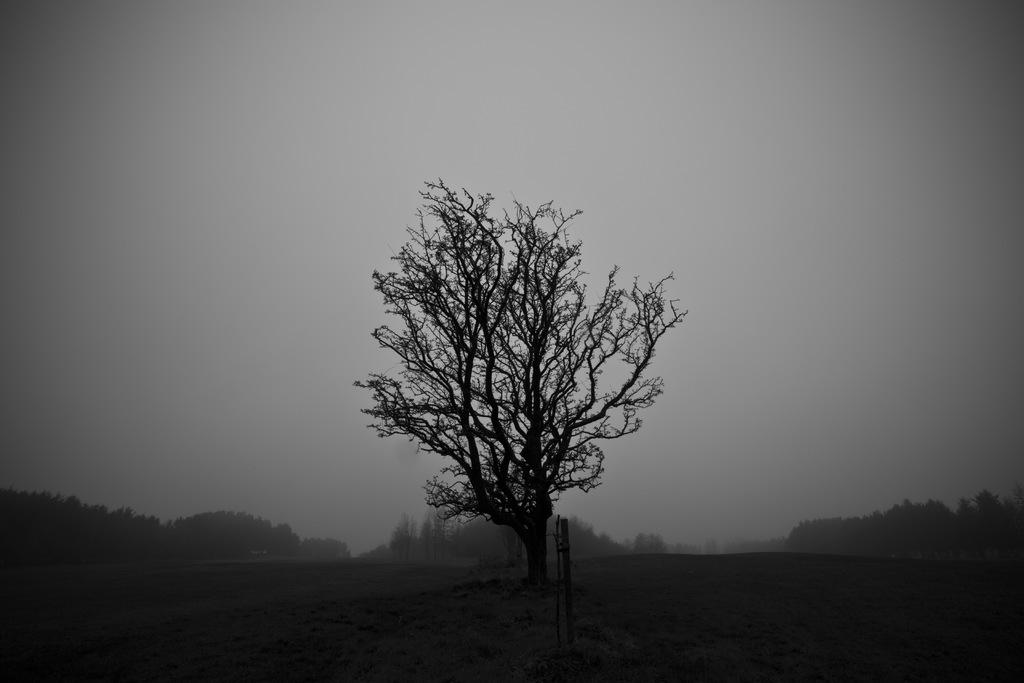What is the main subject in the center of the image? There is a tree in the center of the image. What can be seen in the background of the image? There are many trees in the background of the image. What is visible at the bottom of the image? The ground is visible at the bottom of the image. Where is the basin located in the image? There is no basin present in the image. Can you see a snail crawling on the tree in the image? There is no snail visible on the tree in the image. 